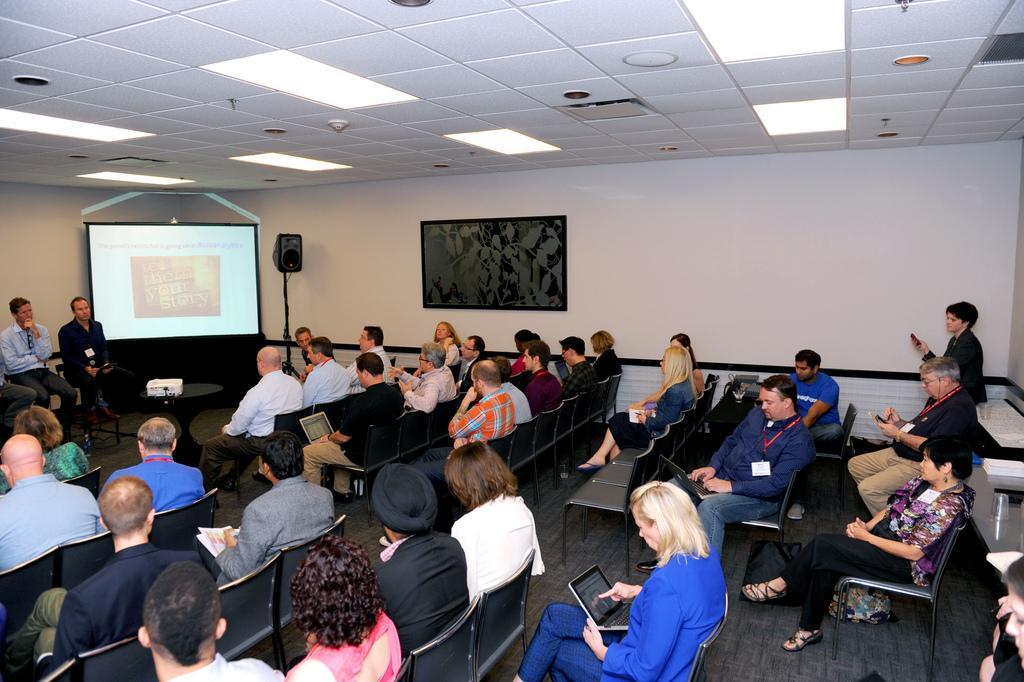In one or two sentences, can you explain what this image depicts? In this picture I can see many persons who are sitting on the chair and some persons are holding the laptop and mobile phone. On the left there are two persons who are sitting near to the projector screen and table. On that table I can see the projector machine. Beside the projector screen there is a speaker which is placed near to the wall. At the top I can see the light on the ceiling. 